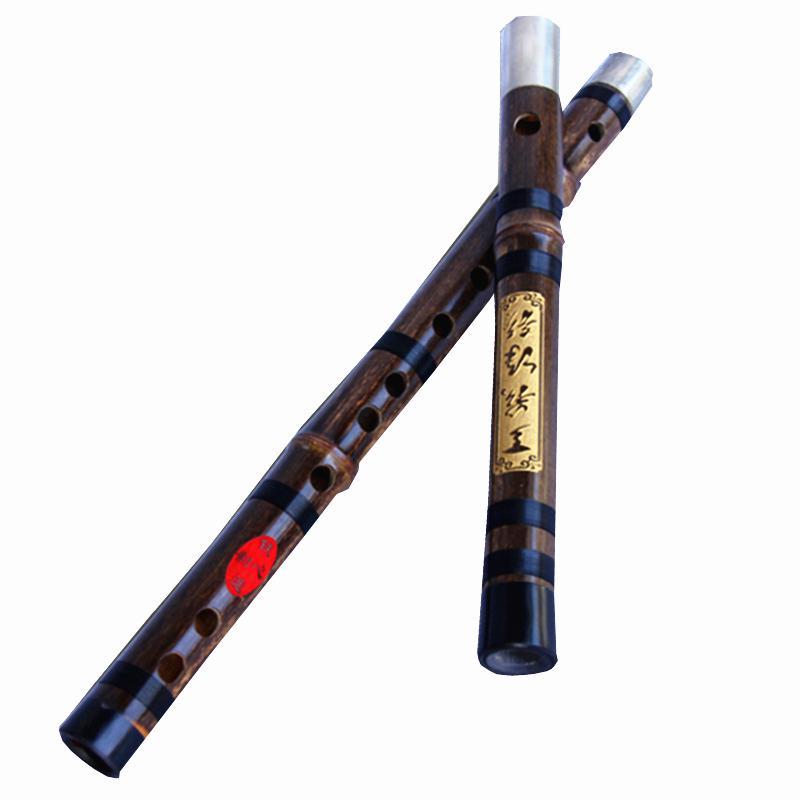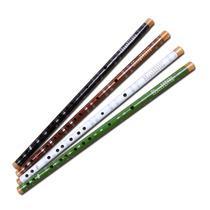The first image is the image on the left, the second image is the image on the right. Given the left and right images, does the statement "One of the instruments is taken apart into two separate pieces." hold true? Answer yes or no. Yes. The first image is the image on the left, the second image is the image on the right. Given the left and right images, does the statement "The left image shows two overlapping, criss-crossed flute parts, and the right image shows at least one flute displayed diagonally." hold true? Answer yes or no. Yes. 